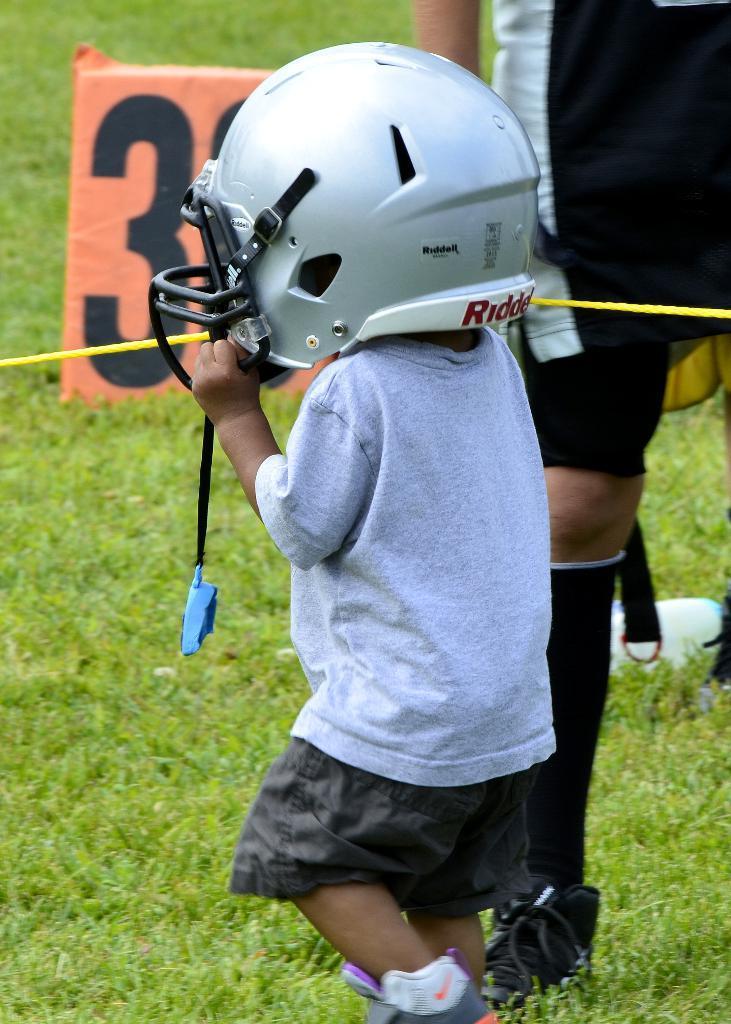How would you summarize this image in a sentence or two? In this image there is a little kid wearing a helmet, beside the kid there is a person standing on the surface of the grass. 